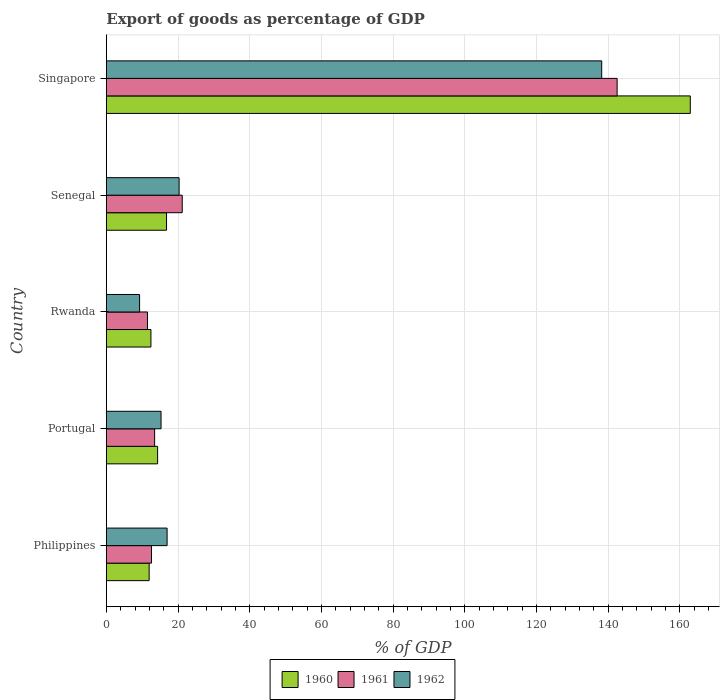How many different coloured bars are there?
Offer a terse response. 3. How many groups of bars are there?
Offer a very short reply. 5. Are the number of bars on each tick of the Y-axis equal?
Provide a short and direct response. Yes. How many bars are there on the 2nd tick from the bottom?
Keep it short and to the point. 3. What is the label of the 2nd group of bars from the top?
Ensure brevity in your answer.  Senegal. In how many cases, is the number of bars for a given country not equal to the number of legend labels?
Make the answer very short. 0. What is the export of goods as percentage of GDP in 1962 in Senegal?
Provide a succinct answer. 20.3. Across all countries, what is the maximum export of goods as percentage of GDP in 1962?
Make the answer very short. 138.18. Across all countries, what is the minimum export of goods as percentage of GDP in 1960?
Your answer should be very brief. 11.95. In which country was the export of goods as percentage of GDP in 1960 maximum?
Offer a very short reply. Singapore. In which country was the export of goods as percentage of GDP in 1961 minimum?
Provide a short and direct response. Rwanda. What is the total export of goods as percentage of GDP in 1962 in the graph?
Your response must be concise. 199.97. What is the difference between the export of goods as percentage of GDP in 1961 in Portugal and that in Rwanda?
Offer a very short reply. 2. What is the difference between the export of goods as percentage of GDP in 1962 in Rwanda and the export of goods as percentage of GDP in 1960 in Singapore?
Offer a very short reply. -153.61. What is the average export of goods as percentage of GDP in 1961 per country?
Provide a succinct answer. 40.24. What is the difference between the export of goods as percentage of GDP in 1960 and export of goods as percentage of GDP in 1961 in Senegal?
Your response must be concise. -4.38. What is the ratio of the export of goods as percentage of GDP in 1962 in Philippines to that in Senegal?
Make the answer very short. 0.83. Is the export of goods as percentage of GDP in 1960 in Philippines less than that in Singapore?
Provide a succinct answer. Yes. Is the difference between the export of goods as percentage of GDP in 1960 in Portugal and Senegal greater than the difference between the export of goods as percentage of GDP in 1961 in Portugal and Senegal?
Provide a succinct answer. Yes. What is the difference between the highest and the second highest export of goods as percentage of GDP in 1962?
Ensure brevity in your answer.  117.88. What is the difference between the highest and the lowest export of goods as percentage of GDP in 1960?
Ensure brevity in your answer.  150.95. In how many countries, is the export of goods as percentage of GDP in 1960 greater than the average export of goods as percentage of GDP in 1960 taken over all countries?
Keep it short and to the point. 1. Is the sum of the export of goods as percentage of GDP in 1962 in Portugal and Rwanda greater than the maximum export of goods as percentage of GDP in 1961 across all countries?
Offer a very short reply. No. What does the 2nd bar from the top in Portugal represents?
Make the answer very short. 1961. What does the 2nd bar from the bottom in Senegal represents?
Keep it short and to the point. 1961. Is it the case that in every country, the sum of the export of goods as percentage of GDP in 1961 and export of goods as percentage of GDP in 1960 is greater than the export of goods as percentage of GDP in 1962?
Offer a very short reply. Yes. How many countries are there in the graph?
Make the answer very short. 5. Does the graph contain any zero values?
Keep it short and to the point. No. How many legend labels are there?
Your response must be concise. 3. What is the title of the graph?
Ensure brevity in your answer.  Export of goods as percentage of GDP. Does "2000" appear as one of the legend labels in the graph?
Provide a short and direct response. No. What is the label or title of the X-axis?
Provide a short and direct response. % of GDP. What is the label or title of the Y-axis?
Provide a succinct answer. Country. What is the % of GDP of 1960 in Philippines?
Offer a terse response. 11.95. What is the % of GDP in 1961 in Philippines?
Make the answer very short. 12.59. What is the % of GDP in 1962 in Philippines?
Provide a short and direct response. 16.95. What is the % of GDP of 1960 in Portugal?
Give a very brief answer. 14.3. What is the % of GDP of 1961 in Portugal?
Provide a succinct answer. 13.47. What is the % of GDP in 1962 in Portugal?
Offer a very short reply. 15.26. What is the % of GDP in 1960 in Rwanda?
Your answer should be compact. 12.44. What is the % of GDP in 1961 in Rwanda?
Provide a succinct answer. 11.48. What is the % of GDP of 1962 in Rwanda?
Offer a terse response. 9.28. What is the % of GDP in 1960 in Senegal?
Give a very brief answer. 16.79. What is the % of GDP of 1961 in Senegal?
Your answer should be compact. 21.17. What is the % of GDP of 1962 in Senegal?
Your response must be concise. 20.3. What is the % of GDP of 1960 in Singapore?
Provide a succinct answer. 162.89. What is the % of GDP in 1961 in Singapore?
Ensure brevity in your answer.  142.48. What is the % of GDP in 1962 in Singapore?
Your response must be concise. 138.18. Across all countries, what is the maximum % of GDP in 1960?
Your response must be concise. 162.89. Across all countries, what is the maximum % of GDP of 1961?
Give a very brief answer. 142.48. Across all countries, what is the maximum % of GDP of 1962?
Keep it short and to the point. 138.18. Across all countries, what is the minimum % of GDP in 1960?
Make the answer very short. 11.95. Across all countries, what is the minimum % of GDP in 1961?
Your response must be concise. 11.48. Across all countries, what is the minimum % of GDP in 1962?
Keep it short and to the point. 9.28. What is the total % of GDP in 1960 in the graph?
Make the answer very short. 218.37. What is the total % of GDP of 1961 in the graph?
Offer a terse response. 201.2. What is the total % of GDP in 1962 in the graph?
Your answer should be very brief. 199.97. What is the difference between the % of GDP in 1960 in Philippines and that in Portugal?
Offer a terse response. -2.36. What is the difference between the % of GDP of 1961 in Philippines and that in Portugal?
Your answer should be compact. -0.88. What is the difference between the % of GDP of 1962 in Philippines and that in Portugal?
Make the answer very short. 1.69. What is the difference between the % of GDP in 1960 in Philippines and that in Rwanda?
Your answer should be compact. -0.49. What is the difference between the % of GDP in 1961 in Philippines and that in Rwanda?
Provide a short and direct response. 1.12. What is the difference between the % of GDP in 1962 in Philippines and that in Rwanda?
Provide a short and direct response. 7.67. What is the difference between the % of GDP in 1960 in Philippines and that in Senegal?
Make the answer very short. -4.85. What is the difference between the % of GDP of 1961 in Philippines and that in Senegal?
Offer a terse response. -8.58. What is the difference between the % of GDP of 1962 in Philippines and that in Senegal?
Keep it short and to the point. -3.35. What is the difference between the % of GDP in 1960 in Philippines and that in Singapore?
Offer a terse response. -150.95. What is the difference between the % of GDP in 1961 in Philippines and that in Singapore?
Make the answer very short. -129.89. What is the difference between the % of GDP in 1962 in Philippines and that in Singapore?
Give a very brief answer. -121.23. What is the difference between the % of GDP of 1960 in Portugal and that in Rwanda?
Ensure brevity in your answer.  1.87. What is the difference between the % of GDP of 1961 in Portugal and that in Rwanda?
Offer a terse response. 2. What is the difference between the % of GDP in 1962 in Portugal and that in Rwanda?
Give a very brief answer. 5.98. What is the difference between the % of GDP of 1960 in Portugal and that in Senegal?
Your answer should be very brief. -2.49. What is the difference between the % of GDP of 1961 in Portugal and that in Senegal?
Your answer should be very brief. -7.7. What is the difference between the % of GDP in 1962 in Portugal and that in Senegal?
Make the answer very short. -5.04. What is the difference between the % of GDP of 1960 in Portugal and that in Singapore?
Give a very brief answer. -148.59. What is the difference between the % of GDP of 1961 in Portugal and that in Singapore?
Provide a succinct answer. -129.01. What is the difference between the % of GDP of 1962 in Portugal and that in Singapore?
Your response must be concise. -122.92. What is the difference between the % of GDP in 1960 in Rwanda and that in Senegal?
Your response must be concise. -4.36. What is the difference between the % of GDP of 1961 in Rwanda and that in Senegal?
Make the answer very short. -9.7. What is the difference between the % of GDP in 1962 in Rwanda and that in Senegal?
Your answer should be very brief. -11.02. What is the difference between the % of GDP in 1960 in Rwanda and that in Singapore?
Offer a very short reply. -150.46. What is the difference between the % of GDP in 1961 in Rwanda and that in Singapore?
Ensure brevity in your answer.  -131.01. What is the difference between the % of GDP in 1962 in Rwanda and that in Singapore?
Keep it short and to the point. -128.9. What is the difference between the % of GDP of 1960 in Senegal and that in Singapore?
Ensure brevity in your answer.  -146.1. What is the difference between the % of GDP of 1961 in Senegal and that in Singapore?
Give a very brief answer. -121.31. What is the difference between the % of GDP of 1962 in Senegal and that in Singapore?
Give a very brief answer. -117.88. What is the difference between the % of GDP in 1960 in Philippines and the % of GDP in 1961 in Portugal?
Provide a short and direct response. -1.52. What is the difference between the % of GDP in 1960 in Philippines and the % of GDP in 1962 in Portugal?
Keep it short and to the point. -3.31. What is the difference between the % of GDP in 1961 in Philippines and the % of GDP in 1962 in Portugal?
Offer a terse response. -2.67. What is the difference between the % of GDP of 1960 in Philippines and the % of GDP of 1961 in Rwanda?
Offer a very short reply. 0.47. What is the difference between the % of GDP in 1960 in Philippines and the % of GDP in 1962 in Rwanda?
Your response must be concise. 2.67. What is the difference between the % of GDP of 1961 in Philippines and the % of GDP of 1962 in Rwanda?
Your answer should be compact. 3.31. What is the difference between the % of GDP of 1960 in Philippines and the % of GDP of 1961 in Senegal?
Offer a terse response. -9.23. What is the difference between the % of GDP in 1960 in Philippines and the % of GDP in 1962 in Senegal?
Your answer should be compact. -8.35. What is the difference between the % of GDP in 1961 in Philippines and the % of GDP in 1962 in Senegal?
Your response must be concise. -7.71. What is the difference between the % of GDP in 1960 in Philippines and the % of GDP in 1961 in Singapore?
Keep it short and to the point. -130.54. What is the difference between the % of GDP in 1960 in Philippines and the % of GDP in 1962 in Singapore?
Your response must be concise. -126.23. What is the difference between the % of GDP in 1961 in Philippines and the % of GDP in 1962 in Singapore?
Your response must be concise. -125.59. What is the difference between the % of GDP of 1960 in Portugal and the % of GDP of 1961 in Rwanda?
Your response must be concise. 2.83. What is the difference between the % of GDP of 1960 in Portugal and the % of GDP of 1962 in Rwanda?
Make the answer very short. 5.02. What is the difference between the % of GDP of 1961 in Portugal and the % of GDP of 1962 in Rwanda?
Offer a very short reply. 4.19. What is the difference between the % of GDP of 1960 in Portugal and the % of GDP of 1961 in Senegal?
Ensure brevity in your answer.  -6.87. What is the difference between the % of GDP in 1960 in Portugal and the % of GDP in 1962 in Senegal?
Your answer should be compact. -6. What is the difference between the % of GDP of 1961 in Portugal and the % of GDP of 1962 in Senegal?
Keep it short and to the point. -6.83. What is the difference between the % of GDP of 1960 in Portugal and the % of GDP of 1961 in Singapore?
Make the answer very short. -128.18. What is the difference between the % of GDP in 1960 in Portugal and the % of GDP in 1962 in Singapore?
Your answer should be compact. -123.88. What is the difference between the % of GDP in 1961 in Portugal and the % of GDP in 1962 in Singapore?
Offer a terse response. -124.71. What is the difference between the % of GDP in 1960 in Rwanda and the % of GDP in 1961 in Senegal?
Make the answer very short. -8.74. What is the difference between the % of GDP in 1960 in Rwanda and the % of GDP in 1962 in Senegal?
Ensure brevity in your answer.  -7.86. What is the difference between the % of GDP of 1961 in Rwanda and the % of GDP of 1962 in Senegal?
Your answer should be very brief. -8.83. What is the difference between the % of GDP in 1960 in Rwanda and the % of GDP in 1961 in Singapore?
Provide a short and direct response. -130.05. What is the difference between the % of GDP in 1960 in Rwanda and the % of GDP in 1962 in Singapore?
Your answer should be very brief. -125.74. What is the difference between the % of GDP in 1961 in Rwanda and the % of GDP in 1962 in Singapore?
Your response must be concise. -126.71. What is the difference between the % of GDP of 1960 in Senegal and the % of GDP of 1961 in Singapore?
Offer a very short reply. -125.69. What is the difference between the % of GDP in 1960 in Senegal and the % of GDP in 1962 in Singapore?
Keep it short and to the point. -121.39. What is the difference between the % of GDP in 1961 in Senegal and the % of GDP in 1962 in Singapore?
Your answer should be very brief. -117.01. What is the average % of GDP in 1960 per country?
Your answer should be compact. 43.67. What is the average % of GDP of 1961 per country?
Your answer should be compact. 40.24. What is the average % of GDP of 1962 per country?
Offer a terse response. 39.99. What is the difference between the % of GDP in 1960 and % of GDP in 1961 in Philippines?
Offer a terse response. -0.65. What is the difference between the % of GDP in 1960 and % of GDP in 1962 in Philippines?
Your answer should be compact. -5. What is the difference between the % of GDP of 1961 and % of GDP of 1962 in Philippines?
Provide a short and direct response. -4.36. What is the difference between the % of GDP of 1960 and % of GDP of 1961 in Portugal?
Your answer should be very brief. 0.83. What is the difference between the % of GDP in 1960 and % of GDP in 1962 in Portugal?
Ensure brevity in your answer.  -0.96. What is the difference between the % of GDP of 1961 and % of GDP of 1962 in Portugal?
Ensure brevity in your answer.  -1.79. What is the difference between the % of GDP in 1960 and % of GDP in 1961 in Rwanda?
Make the answer very short. 0.96. What is the difference between the % of GDP in 1960 and % of GDP in 1962 in Rwanda?
Provide a succinct answer. 3.16. What is the difference between the % of GDP in 1961 and % of GDP in 1962 in Rwanda?
Your answer should be compact. 2.2. What is the difference between the % of GDP in 1960 and % of GDP in 1961 in Senegal?
Give a very brief answer. -4.38. What is the difference between the % of GDP of 1960 and % of GDP of 1962 in Senegal?
Ensure brevity in your answer.  -3.51. What is the difference between the % of GDP of 1961 and % of GDP of 1962 in Senegal?
Your answer should be very brief. 0.87. What is the difference between the % of GDP in 1960 and % of GDP in 1961 in Singapore?
Your response must be concise. 20.41. What is the difference between the % of GDP in 1960 and % of GDP in 1962 in Singapore?
Your answer should be very brief. 24.71. What is the difference between the % of GDP in 1961 and % of GDP in 1962 in Singapore?
Your response must be concise. 4.3. What is the ratio of the % of GDP in 1960 in Philippines to that in Portugal?
Offer a terse response. 0.84. What is the ratio of the % of GDP of 1961 in Philippines to that in Portugal?
Ensure brevity in your answer.  0.93. What is the ratio of the % of GDP of 1962 in Philippines to that in Portugal?
Your answer should be very brief. 1.11. What is the ratio of the % of GDP of 1960 in Philippines to that in Rwanda?
Give a very brief answer. 0.96. What is the ratio of the % of GDP of 1961 in Philippines to that in Rwanda?
Offer a terse response. 1.1. What is the ratio of the % of GDP of 1962 in Philippines to that in Rwanda?
Your answer should be very brief. 1.83. What is the ratio of the % of GDP of 1960 in Philippines to that in Senegal?
Your response must be concise. 0.71. What is the ratio of the % of GDP in 1961 in Philippines to that in Senegal?
Provide a short and direct response. 0.59. What is the ratio of the % of GDP of 1962 in Philippines to that in Senegal?
Ensure brevity in your answer.  0.83. What is the ratio of the % of GDP of 1960 in Philippines to that in Singapore?
Keep it short and to the point. 0.07. What is the ratio of the % of GDP in 1961 in Philippines to that in Singapore?
Your answer should be compact. 0.09. What is the ratio of the % of GDP in 1962 in Philippines to that in Singapore?
Provide a succinct answer. 0.12. What is the ratio of the % of GDP in 1960 in Portugal to that in Rwanda?
Provide a short and direct response. 1.15. What is the ratio of the % of GDP in 1961 in Portugal to that in Rwanda?
Your answer should be very brief. 1.17. What is the ratio of the % of GDP of 1962 in Portugal to that in Rwanda?
Your response must be concise. 1.64. What is the ratio of the % of GDP in 1960 in Portugal to that in Senegal?
Keep it short and to the point. 0.85. What is the ratio of the % of GDP of 1961 in Portugal to that in Senegal?
Offer a very short reply. 0.64. What is the ratio of the % of GDP in 1962 in Portugal to that in Senegal?
Offer a very short reply. 0.75. What is the ratio of the % of GDP of 1960 in Portugal to that in Singapore?
Keep it short and to the point. 0.09. What is the ratio of the % of GDP in 1961 in Portugal to that in Singapore?
Your answer should be very brief. 0.09. What is the ratio of the % of GDP in 1962 in Portugal to that in Singapore?
Give a very brief answer. 0.11. What is the ratio of the % of GDP in 1960 in Rwanda to that in Senegal?
Give a very brief answer. 0.74. What is the ratio of the % of GDP in 1961 in Rwanda to that in Senegal?
Your answer should be compact. 0.54. What is the ratio of the % of GDP of 1962 in Rwanda to that in Senegal?
Offer a very short reply. 0.46. What is the ratio of the % of GDP of 1960 in Rwanda to that in Singapore?
Offer a terse response. 0.08. What is the ratio of the % of GDP of 1961 in Rwanda to that in Singapore?
Your answer should be very brief. 0.08. What is the ratio of the % of GDP in 1962 in Rwanda to that in Singapore?
Ensure brevity in your answer.  0.07. What is the ratio of the % of GDP in 1960 in Senegal to that in Singapore?
Your answer should be very brief. 0.1. What is the ratio of the % of GDP of 1961 in Senegal to that in Singapore?
Make the answer very short. 0.15. What is the ratio of the % of GDP in 1962 in Senegal to that in Singapore?
Make the answer very short. 0.15. What is the difference between the highest and the second highest % of GDP in 1960?
Your answer should be very brief. 146.1. What is the difference between the highest and the second highest % of GDP in 1961?
Provide a succinct answer. 121.31. What is the difference between the highest and the second highest % of GDP in 1962?
Offer a very short reply. 117.88. What is the difference between the highest and the lowest % of GDP of 1960?
Provide a short and direct response. 150.95. What is the difference between the highest and the lowest % of GDP of 1961?
Ensure brevity in your answer.  131.01. What is the difference between the highest and the lowest % of GDP in 1962?
Give a very brief answer. 128.9. 